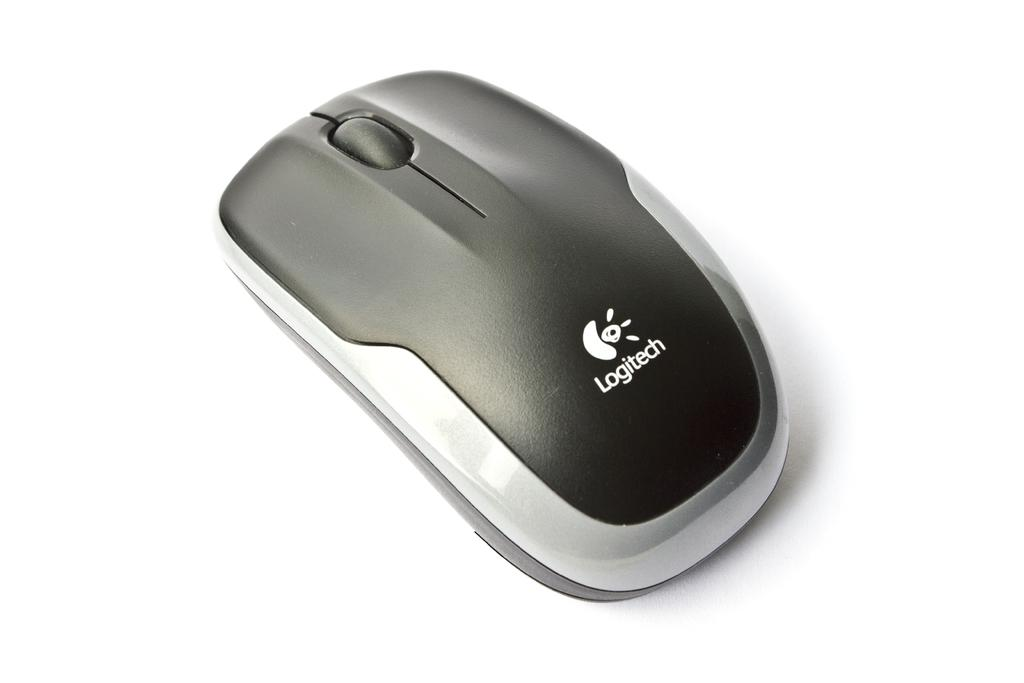What type of animal is present in the image? There is a mouse in the image. What type of seat is the mouse sitting on in the image? There is no seat present in the image; it only features a mouse. Who is the uncle of the mouse in the image? There is no indication of any family relationships in the image, as it only features a mouse. 